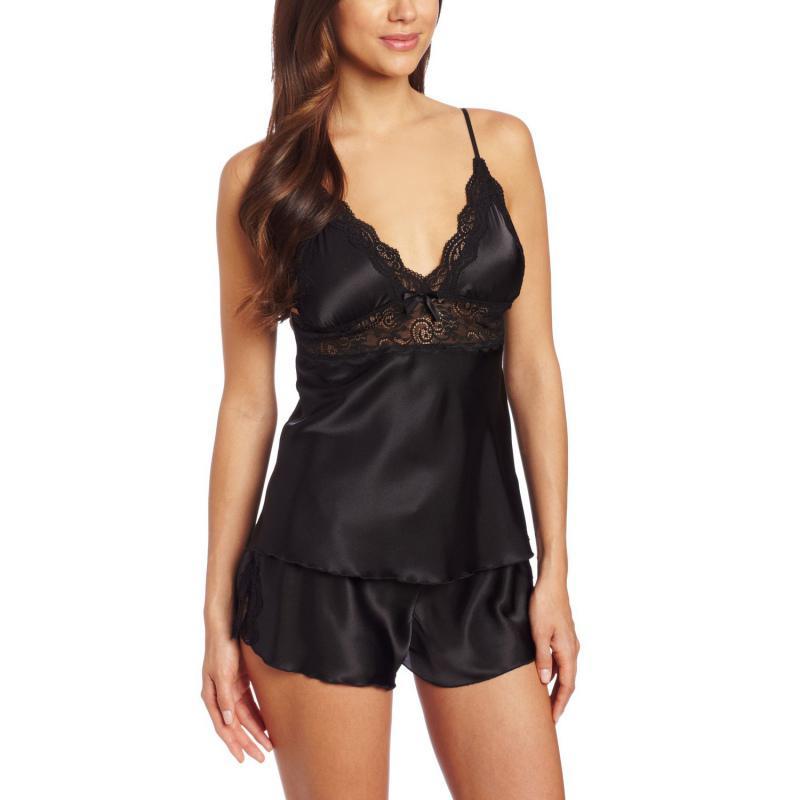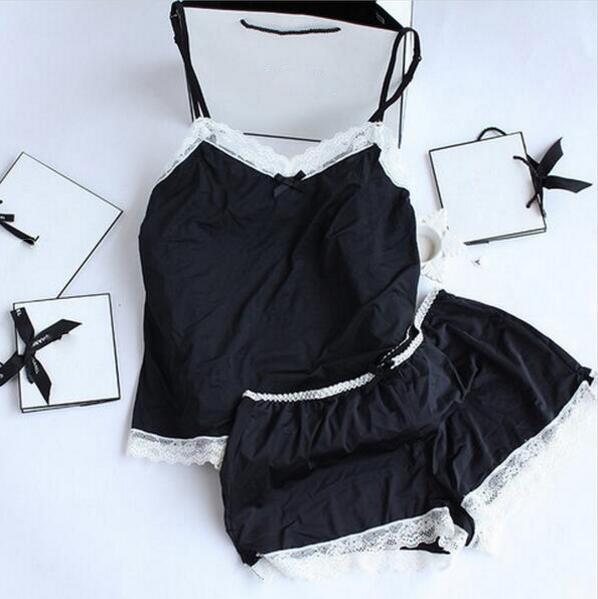The first image is the image on the left, the second image is the image on the right. Assess this claim about the two images: "In one image, a woman is wearing a black pajama set that is comprised of shorts and a camisole top". Correct or not? Answer yes or no. Yes. The first image is the image on the left, the second image is the image on the right. Given the left and right images, does the statement "One image contains a women wearing black sleep attire." hold true? Answer yes or no. Yes. 